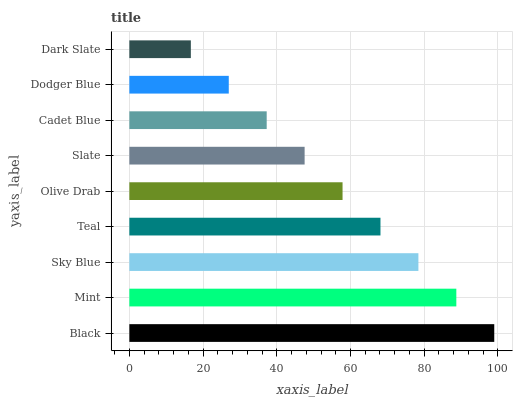Is Dark Slate the minimum?
Answer yes or no. Yes. Is Black the maximum?
Answer yes or no. Yes. Is Mint the minimum?
Answer yes or no. No. Is Mint the maximum?
Answer yes or no. No. Is Black greater than Mint?
Answer yes or no. Yes. Is Mint less than Black?
Answer yes or no. Yes. Is Mint greater than Black?
Answer yes or no. No. Is Black less than Mint?
Answer yes or no. No. Is Olive Drab the high median?
Answer yes or no. Yes. Is Olive Drab the low median?
Answer yes or no. Yes. Is Sky Blue the high median?
Answer yes or no. No. Is Slate the low median?
Answer yes or no. No. 